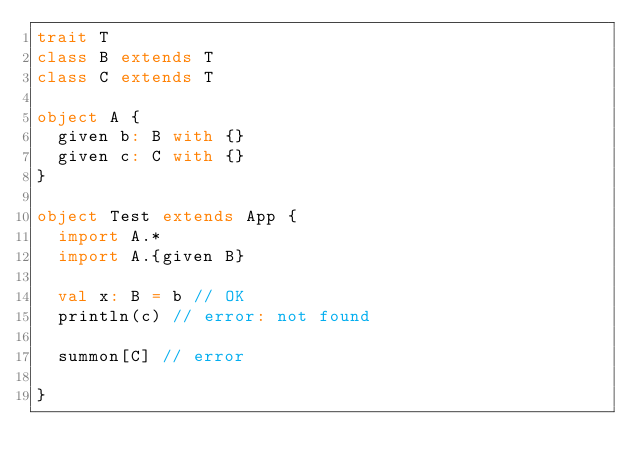Convert code to text. <code><loc_0><loc_0><loc_500><loc_500><_Scala_>trait T
class B extends T
class C extends T

object A {
  given b: B with {}
  given c: C with {}
}

object Test extends App {
  import A.*
  import A.{given B}

  val x: B = b // OK
  println(c) // error: not found

  summon[C] // error

}</code> 